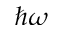<formula> <loc_0><loc_0><loc_500><loc_500>\hbar { \omega }</formula> 